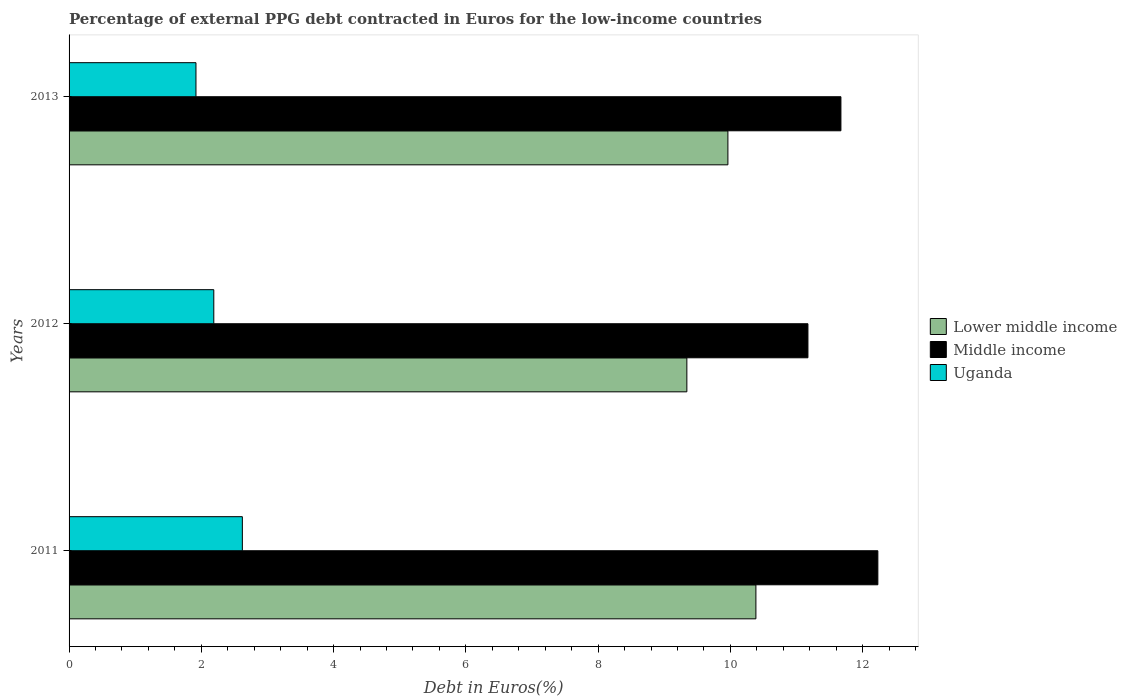How many different coloured bars are there?
Offer a very short reply. 3. How many groups of bars are there?
Provide a succinct answer. 3. Are the number of bars per tick equal to the number of legend labels?
Your answer should be very brief. Yes. Are the number of bars on each tick of the Y-axis equal?
Make the answer very short. Yes. How many bars are there on the 2nd tick from the bottom?
Provide a succinct answer. 3. In how many cases, is the number of bars for a given year not equal to the number of legend labels?
Keep it short and to the point. 0. What is the percentage of external PPG debt contracted in Euros in Middle income in 2012?
Give a very brief answer. 11.17. Across all years, what is the maximum percentage of external PPG debt contracted in Euros in Uganda?
Make the answer very short. 2.62. Across all years, what is the minimum percentage of external PPG debt contracted in Euros in Uganda?
Provide a succinct answer. 1.92. In which year was the percentage of external PPG debt contracted in Euros in Middle income maximum?
Your answer should be compact. 2011. What is the total percentage of external PPG debt contracted in Euros in Middle income in the graph?
Ensure brevity in your answer.  35.08. What is the difference between the percentage of external PPG debt contracted in Euros in Middle income in 2011 and that in 2012?
Offer a very short reply. 1.06. What is the difference between the percentage of external PPG debt contracted in Euros in Uganda in 2011 and the percentage of external PPG debt contracted in Euros in Lower middle income in 2013?
Offer a very short reply. -7.34. What is the average percentage of external PPG debt contracted in Euros in Middle income per year?
Keep it short and to the point. 11.69. In the year 2012, what is the difference between the percentage of external PPG debt contracted in Euros in Uganda and percentage of external PPG debt contracted in Euros in Middle income?
Your answer should be very brief. -8.98. What is the ratio of the percentage of external PPG debt contracted in Euros in Uganda in 2011 to that in 2012?
Give a very brief answer. 1.2. Is the percentage of external PPG debt contracted in Euros in Lower middle income in 2011 less than that in 2013?
Your answer should be very brief. No. Is the difference between the percentage of external PPG debt contracted in Euros in Uganda in 2011 and 2013 greater than the difference between the percentage of external PPG debt contracted in Euros in Middle income in 2011 and 2013?
Give a very brief answer. Yes. What is the difference between the highest and the second highest percentage of external PPG debt contracted in Euros in Middle income?
Your answer should be very brief. 0.56. What is the difference between the highest and the lowest percentage of external PPG debt contracted in Euros in Lower middle income?
Ensure brevity in your answer.  1.04. In how many years, is the percentage of external PPG debt contracted in Euros in Middle income greater than the average percentage of external PPG debt contracted in Euros in Middle income taken over all years?
Provide a succinct answer. 1. What does the 1st bar from the top in 2013 represents?
Your answer should be compact. Uganda. What does the 2nd bar from the bottom in 2012 represents?
Keep it short and to the point. Middle income. Is it the case that in every year, the sum of the percentage of external PPG debt contracted in Euros in Middle income and percentage of external PPG debt contracted in Euros in Uganda is greater than the percentage of external PPG debt contracted in Euros in Lower middle income?
Your answer should be very brief. Yes. How many years are there in the graph?
Make the answer very short. 3. What is the difference between two consecutive major ticks on the X-axis?
Your answer should be compact. 2. Are the values on the major ticks of X-axis written in scientific E-notation?
Provide a short and direct response. No. Does the graph contain any zero values?
Make the answer very short. No. Where does the legend appear in the graph?
Keep it short and to the point. Center right. How are the legend labels stacked?
Your response must be concise. Vertical. What is the title of the graph?
Your response must be concise. Percentage of external PPG debt contracted in Euros for the low-income countries. Does "France" appear as one of the legend labels in the graph?
Provide a succinct answer. No. What is the label or title of the X-axis?
Provide a short and direct response. Debt in Euros(%). What is the label or title of the Y-axis?
Your response must be concise. Years. What is the Debt in Euros(%) in Lower middle income in 2011?
Your response must be concise. 10.39. What is the Debt in Euros(%) of Middle income in 2011?
Your answer should be very brief. 12.23. What is the Debt in Euros(%) in Uganda in 2011?
Give a very brief answer. 2.62. What is the Debt in Euros(%) of Lower middle income in 2012?
Ensure brevity in your answer.  9.34. What is the Debt in Euros(%) of Middle income in 2012?
Your answer should be compact. 11.17. What is the Debt in Euros(%) of Uganda in 2012?
Provide a short and direct response. 2.19. What is the Debt in Euros(%) of Lower middle income in 2013?
Your response must be concise. 9.96. What is the Debt in Euros(%) of Middle income in 2013?
Keep it short and to the point. 11.67. What is the Debt in Euros(%) in Uganda in 2013?
Offer a terse response. 1.92. Across all years, what is the maximum Debt in Euros(%) in Lower middle income?
Provide a succinct answer. 10.39. Across all years, what is the maximum Debt in Euros(%) in Middle income?
Keep it short and to the point. 12.23. Across all years, what is the maximum Debt in Euros(%) in Uganda?
Give a very brief answer. 2.62. Across all years, what is the minimum Debt in Euros(%) of Lower middle income?
Your answer should be compact. 9.34. Across all years, what is the minimum Debt in Euros(%) of Middle income?
Offer a very short reply. 11.17. Across all years, what is the minimum Debt in Euros(%) in Uganda?
Your answer should be compact. 1.92. What is the total Debt in Euros(%) of Lower middle income in the graph?
Make the answer very short. 29.69. What is the total Debt in Euros(%) in Middle income in the graph?
Offer a terse response. 35.08. What is the total Debt in Euros(%) of Uganda in the graph?
Ensure brevity in your answer.  6.73. What is the difference between the Debt in Euros(%) in Lower middle income in 2011 and that in 2012?
Offer a terse response. 1.04. What is the difference between the Debt in Euros(%) in Middle income in 2011 and that in 2012?
Your answer should be very brief. 1.06. What is the difference between the Debt in Euros(%) in Uganda in 2011 and that in 2012?
Offer a terse response. 0.43. What is the difference between the Debt in Euros(%) in Lower middle income in 2011 and that in 2013?
Offer a terse response. 0.42. What is the difference between the Debt in Euros(%) of Middle income in 2011 and that in 2013?
Your answer should be compact. 0.56. What is the difference between the Debt in Euros(%) in Uganda in 2011 and that in 2013?
Make the answer very short. 0.7. What is the difference between the Debt in Euros(%) of Lower middle income in 2012 and that in 2013?
Provide a short and direct response. -0.62. What is the difference between the Debt in Euros(%) in Middle income in 2012 and that in 2013?
Make the answer very short. -0.5. What is the difference between the Debt in Euros(%) in Uganda in 2012 and that in 2013?
Give a very brief answer. 0.27. What is the difference between the Debt in Euros(%) of Lower middle income in 2011 and the Debt in Euros(%) of Middle income in 2012?
Provide a succinct answer. -0.79. What is the difference between the Debt in Euros(%) in Lower middle income in 2011 and the Debt in Euros(%) in Uganda in 2012?
Ensure brevity in your answer.  8.2. What is the difference between the Debt in Euros(%) of Middle income in 2011 and the Debt in Euros(%) of Uganda in 2012?
Your answer should be very brief. 10.04. What is the difference between the Debt in Euros(%) of Lower middle income in 2011 and the Debt in Euros(%) of Middle income in 2013?
Your response must be concise. -1.29. What is the difference between the Debt in Euros(%) of Lower middle income in 2011 and the Debt in Euros(%) of Uganda in 2013?
Provide a short and direct response. 8.47. What is the difference between the Debt in Euros(%) in Middle income in 2011 and the Debt in Euros(%) in Uganda in 2013?
Offer a terse response. 10.31. What is the difference between the Debt in Euros(%) of Lower middle income in 2012 and the Debt in Euros(%) of Middle income in 2013?
Your response must be concise. -2.33. What is the difference between the Debt in Euros(%) in Lower middle income in 2012 and the Debt in Euros(%) in Uganda in 2013?
Provide a succinct answer. 7.42. What is the difference between the Debt in Euros(%) of Middle income in 2012 and the Debt in Euros(%) of Uganda in 2013?
Your response must be concise. 9.25. What is the average Debt in Euros(%) in Lower middle income per year?
Provide a short and direct response. 9.9. What is the average Debt in Euros(%) of Middle income per year?
Your response must be concise. 11.69. What is the average Debt in Euros(%) in Uganda per year?
Provide a short and direct response. 2.24. In the year 2011, what is the difference between the Debt in Euros(%) of Lower middle income and Debt in Euros(%) of Middle income?
Give a very brief answer. -1.84. In the year 2011, what is the difference between the Debt in Euros(%) in Lower middle income and Debt in Euros(%) in Uganda?
Keep it short and to the point. 7.77. In the year 2011, what is the difference between the Debt in Euros(%) of Middle income and Debt in Euros(%) of Uganda?
Ensure brevity in your answer.  9.61. In the year 2012, what is the difference between the Debt in Euros(%) in Lower middle income and Debt in Euros(%) in Middle income?
Offer a very short reply. -1.83. In the year 2012, what is the difference between the Debt in Euros(%) of Lower middle income and Debt in Euros(%) of Uganda?
Offer a terse response. 7.15. In the year 2012, what is the difference between the Debt in Euros(%) of Middle income and Debt in Euros(%) of Uganda?
Give a very brief answer. 8.98. In the year 2013, what is the difference between the Debt in Euros(%) of Lower middle income and Debt in Euros(%) of Middle income?
Ensure brevity in your answer.  -1.71. In the year 2013, what is the difference between the Debt in Euros(%) of Lower middle income and Debt in Euros(%) of Uganda?
Provide a succinct answer. 8.04. In the year 2013, what is the difference between the Debt in Euros(%) in Middle income and Debt in Euros(%) in Uganda?
Your answer should be very brief. 9.75. What is the ratio of the Debt in Euros(%) in Lower middle income in 2011 to that in 2012?
Offer a terse response. 1.11. What is the ratio of the Debt in Euros(%) in Middle income in 2011 to that in 2012?
Your answer should be compact. 1.09. What is the ratio of the Debt in Euros(%) in Uganda in 2011 to that in 2012?
Give a very brief answer. 1.2. What is the ratio of the Debt in Euros(%) in Lower middle income in 2011 to that in 2013?
Keep it short and to the point. 1.04. What is the ratio of the Debt in Euros(%) of Middle income in 2011 to that in 2013?
Ensure brevity in your answer.  1.05. What is the ratio of the Debt in Euros(%) in Uganda in 2011 to that in 2013?
Your answer should be very brief. 1.37. What is the ratio of the Debt in Euros(%) of Lower middle income in 2012 to that in 2013?
Your answer should be compact. 0.94. What is the ratio of the Debt in Euros(%) of Middle income in 2012 to that in 2013?
Keep it short and to the point. 0.96. What is the ratio of the Debt in Euros(%) in Uganda in 2012 to that in 2013?
Make the answer very short. 1.14. What is the difference between the highest and the second highest Debt in Euros(%) of Lower middle income?
Make the answer very short. 0.42. What is the difference between the highest and the second highest Debt in Euros(%) in Middle income?
Offer a very short reply. 0.56. What is the difference between the highest and the second highest Debt in Euros(%) of Uganda?
Your response must be concise. 0.43. What is the difference between the highest and the lowest Debt in Euros(%) of Lower middle income?
Your answer should be very brief. 1.04. What is the difference between the highest and the lowest Debt in Euros(%) of Middle income?
Your answer should be very brief. 1.06. What is the difference between the highest and the lowest Debt in Euros(%) of Uganda?
Keep it short and to the point. 0.7. 